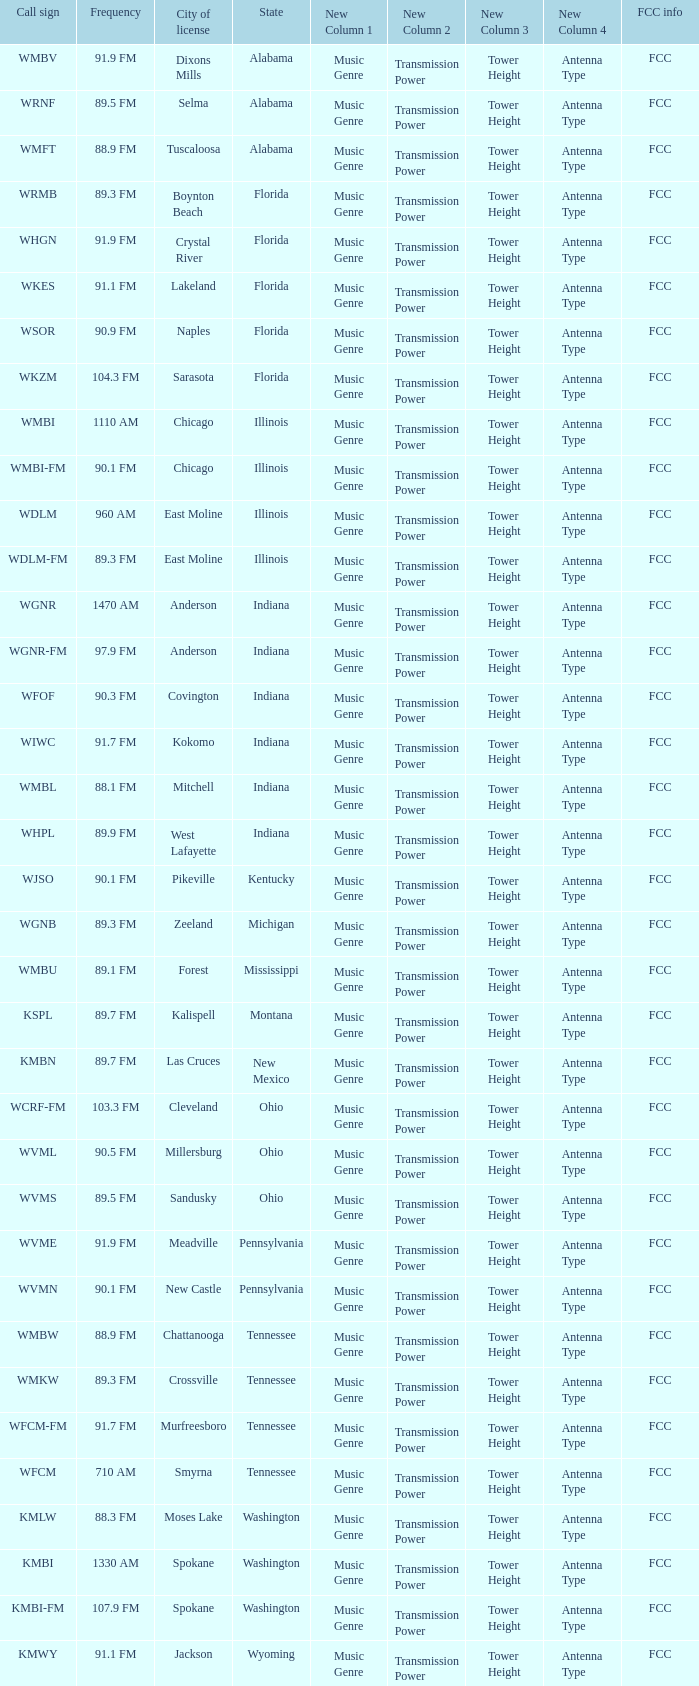What is the frequency of the radio station with a call sign of WGNR-FM? 97.9 FM. 